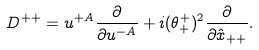Convert formula to latex. <formula><loc_0><loc_0><loc_500><loc_500>D ^ { + + } = u ^ { + A } \frac { \partial } { \partial u ^ { - A } } + i ( \theta _ { + } ^ { + } ) ^ { 2 } \frac { \partial } { \partial \hat { x } _ { + + } } .</formula> 